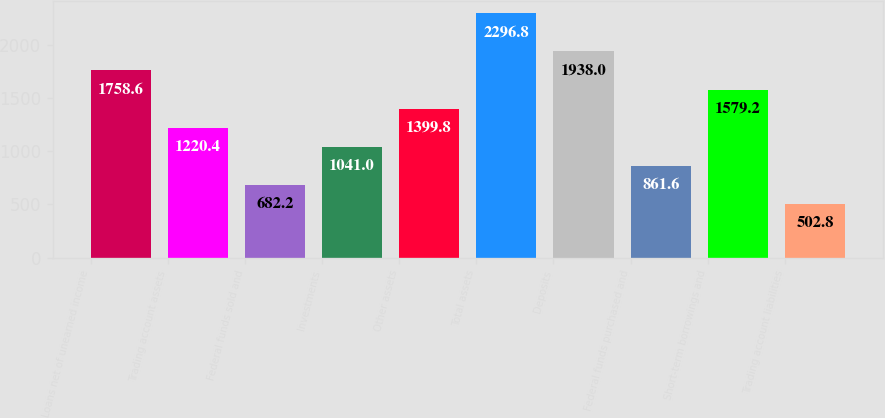Convert chart. <chart><loc_0><loc_0><loc_500><loc_500><bar_chart><fcel>Loans net of unearned income<fcel>Trading account assets<fcel>Federal funds sold and<fcel>Investments<fcel>Other assets<fcel>Total assets<fcel>Deposits<fcel>Federal funds purchased and<fcel>Short-term borrowings and<fcel>Trading account liabilities<nl><fcel>1758.6<fcel>1220.4<fcel>682.2<fcel>1041<fcel>1399.8<fcel>2296.8<fcel>1938<fcel>861.6<fcel>1579.2<fcel>502.8<nl></chart> 